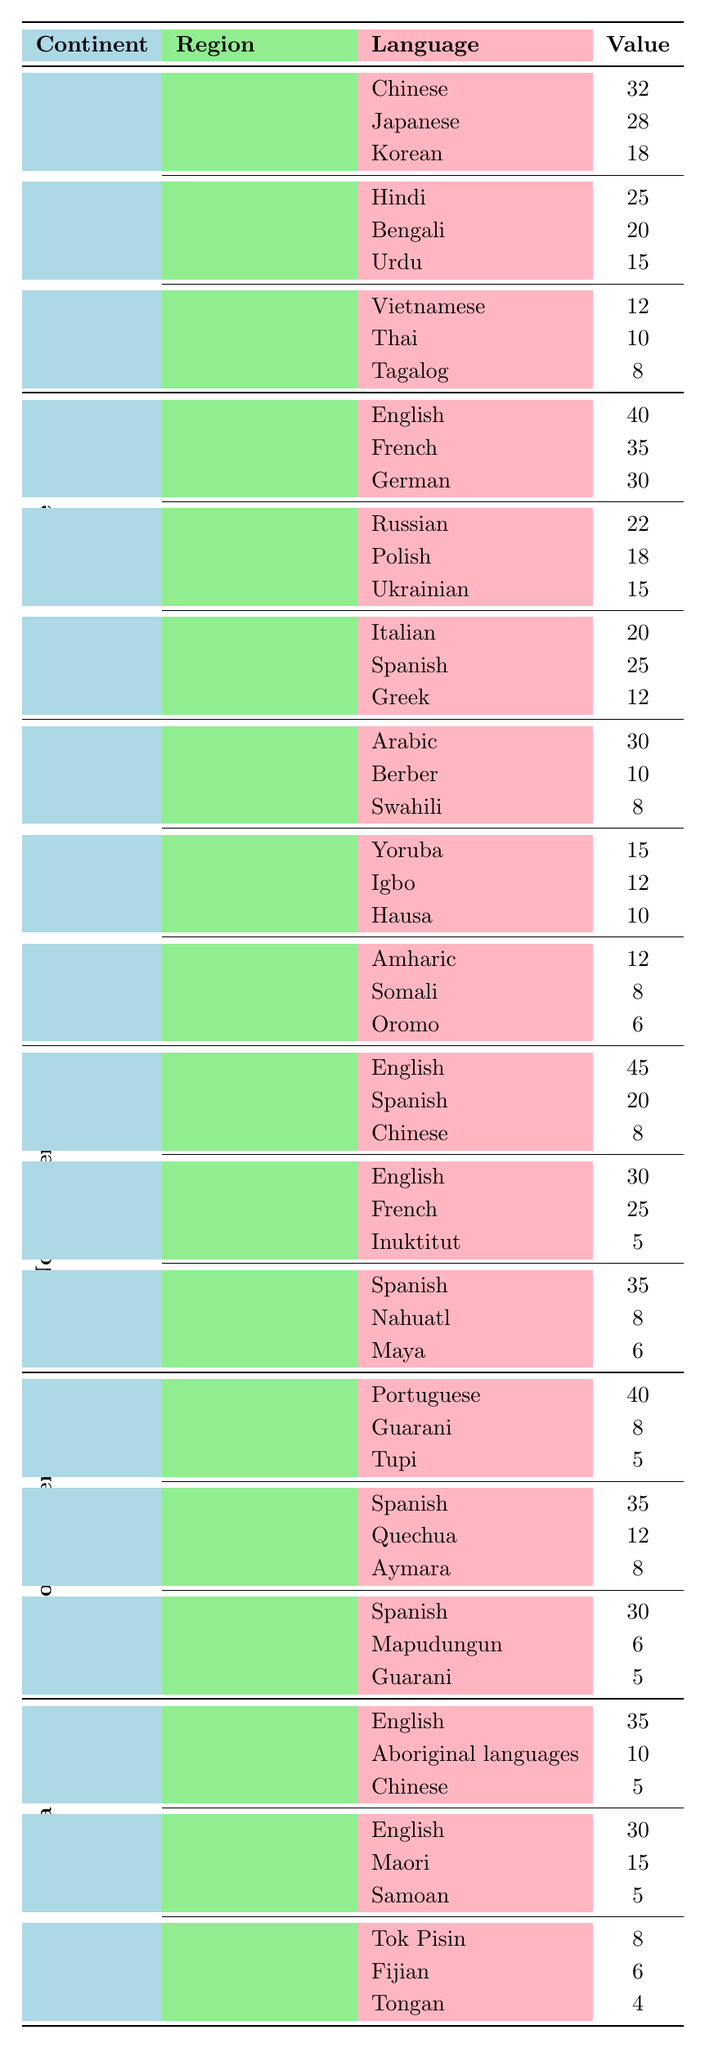What is the most represented language in North America? From the North America section, the language with the highest value is English, which has a count of 45.
Answer: English Which region in Europe has the least representation? In the European section, the region with the least representation when considering language values is Southern Europe, with Greek being the lowest value at 12.
Answer: Greek How many languages are listed under East Africa? The East Africa region includes three languages: Amharic, Somali, and Oromo. Therefore, the total number of languages listed is 3.
Answer: 3 What is the total value of languages in South America? Adding the values of the languages under each region of South America: Brazil (53), Andean Region (55), Southern Cone (41) gives a total of 53 + 55 + 41 = 149.
Answer: 149 Is there more representation for languages in West Africa compared to North Africa? In West Africa, the total values are 15 (Yoruba) + 12 (Igbo) + 10 (Hausa) = 37. In North Africa, the total is 30 (Arabic) + 10 (Berber) + 8 (Swahili) = 48. Thus, it's false that West Africa has more representation.
Answer: No What is the combined value of languages spoken in the Southern Cone? The languages in the Southern Cone are Spanish (30), Mapudungun (6), and Guarani (5). Their total value is 30 + 6 + 5 = 41.
Answer: 41 Which continent has the highest representation of languages overall? By adding up the total values for each continent, Asia has 32 + 28 + 18 + 25 + 20 + 15 + 12 + 10 + 8 = 168, Europe has 40 + 35 + 30 + 22 + 18 + 15 + 20 + 25 + 12 = 247, Africa has 30 + 10 + 8 + 15 + 12 + 10 + 12 + 8 + 6 = 81, North America has 45 + 20 + 8 + 30 + 25 + 5 + 35 + 8 + 6 = 182, South America has 40 + 8 + 5 + 35 + 12 + 8 + 30 + 6 + 5 = 149, and Oceania has 35 + 10 + 5 + 30 + 15 + 5 + 8 + 6 + 4 = 118. Thus, Europe has the highest representation.
Answer: Europe How does the total representation of languages in East Asia compare to that in the Southern Europe? For East Asia, the total is 32 (Chinese) + 28 (Japanese) + 18 (Korean) = 78. For Southern Europe, it is 20 (Italian) + 25 (Spanish) + 12 (Greek) = 57. Therefore, East Asia has a higher representation.
Answer: East Asia Which language has the highest representation in Africa? Arabic is the language with the highest representation in Africa, with a count of 30.
Answer: Arabic 